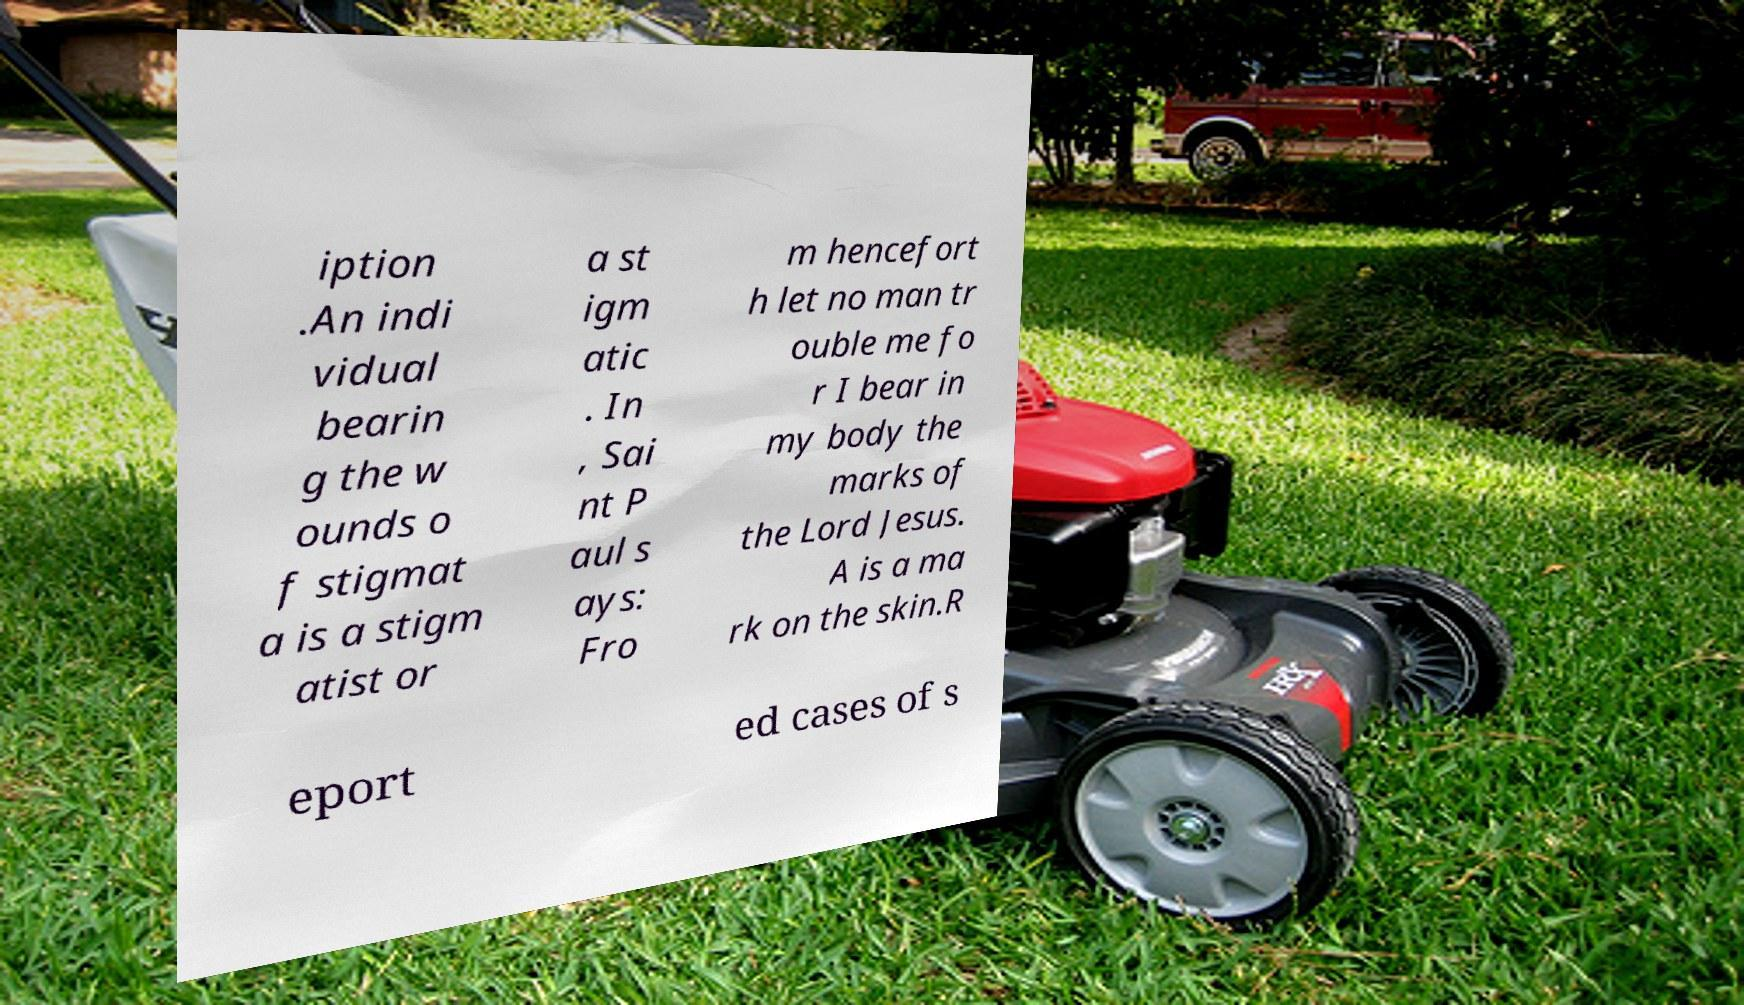For documentation purposes, I need the text within this image transcribed. Could you provide that? iption .An indi vidual bearin g the w ounds o f stigmat a is a stigm atist or a st igm atic . In , Sai nt P aul s ays: Fro m hencefort h let no man tr ouble me fo r I bear in my body the marks of the Lord Jesus. A is a ma rk on the skin.R eport ed cases of s 